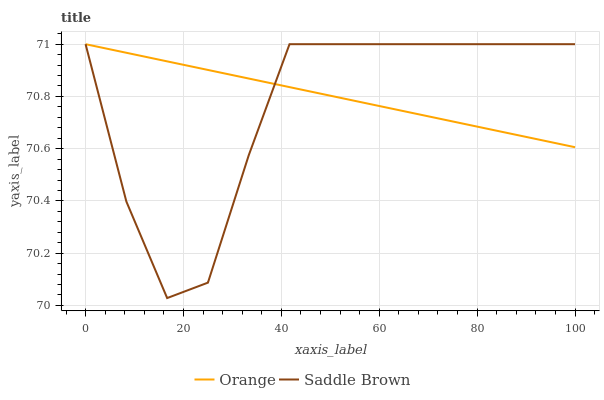Does Saddle Brown have the minimum area under the curve?
Answer yes or no. Yes. Does Orange have the maximum area under the curve?
Answer yes or no. Yes. Does Saddle Brown have the maximum area under the curve?
Answer yes or no. No. Is Orange the smoothest?
Answer yes or no. Yes. Is Saddle Brown the roughest?
Answer yes or no. Yes. Is Saddle Brown the smoothest?
Answer yes or no. No. Does Saddle Brown have the lowest value?
Answer yes or no. Yes. Does Saddle Brown have the highest value?
Answer yes or no. Yes. Does Saddle Brown intersect Orange?
Answer yes or no. Yes. Is Saddle Brown less than Orange?
Answer yes or no. No. Is Saddle Brown greater than Orange?
Answer yes or no. No. 